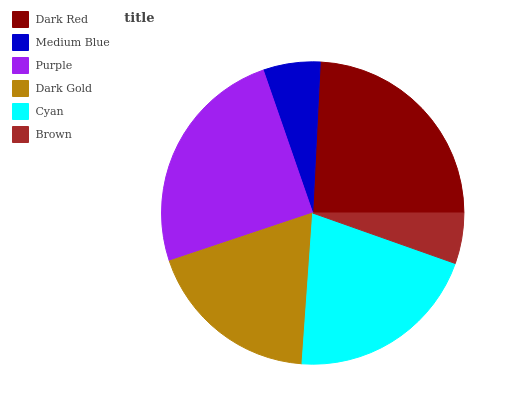Is Brown the minimum?
Answer yes or no. Yes. Is Purple the maximum?
Answer yes or no. Yes. Is Medium Blue the minimum?
Answer yes or no. No. Is Medium Blue the maximum?
Answer yes or no. No. Is Dark Red greater than Medium Blue?
Answer yes or no. Yes. Is Medium Blue less than Dark Red?
Answer yes or no. Yes. Is Medium Blue greater than Dark Red?
Answer yes or no. No. Is Dark Red less than Medium Blue?
Answer yes or no. No. Is Cyan the high median?
Answer yes or no. Yes. Is Dark Gold the low median?
Answer yes or no. Yes. Is Medium Blue the high median?
Answer yes or no. No. Is Cyan the low median?
Answer yes or no. No. 